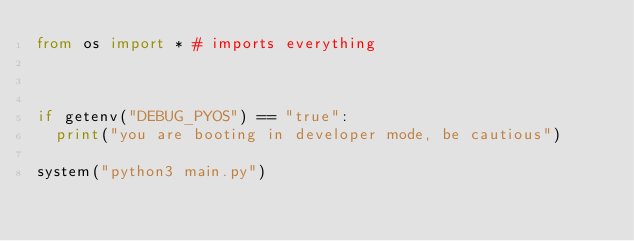Convert code to text. <code><loc_0><loc_0><loc_500><loc_500><_Python_>from os import * # imports everything



if getenv("DEBUG_PYOS") == "true":
  print("you are booting in developer mode, be cautious")
  
system("python3 main.py")</code> 